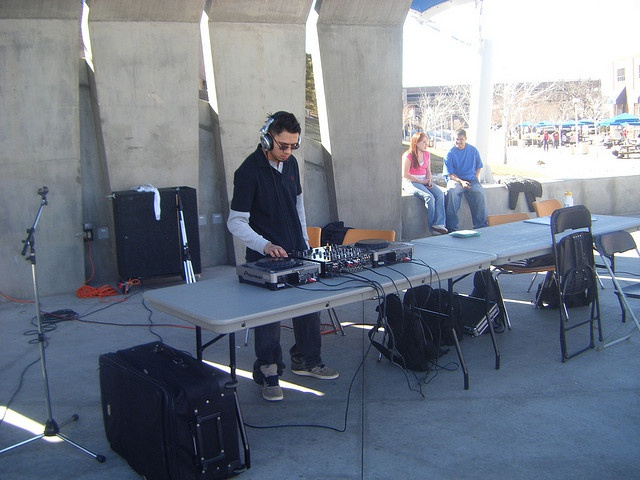Describe the objects in this image and their specific colors. I can see suitcase in gray, black, navy, and darkblue tones, people in gray, black, and darkgray tones, chair in gray, black, and darkblue tones, chair in gray and darkgray tones, and people in gray and darkgray tones in this image. 